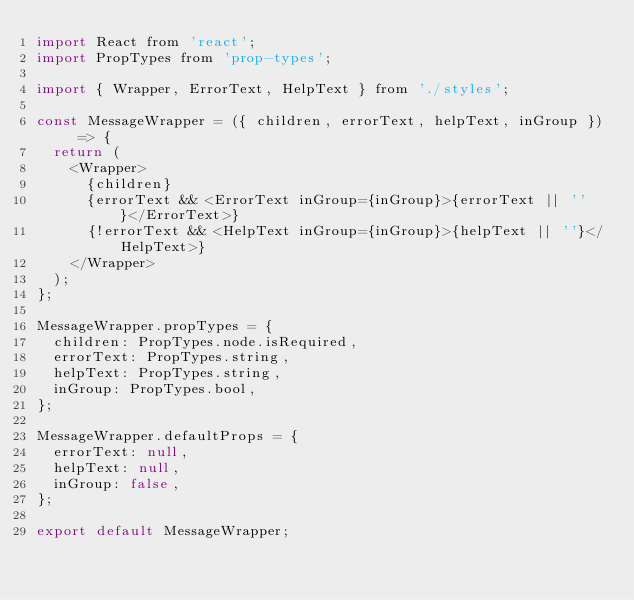Convert code to text. <code><loc_0><loc_0><loc_500><loc_500><_JavaScript_>import React from 'react';
import PropTypes from 'prop-types';

import { Wrapper, ErrorText, HelpText } from './styles';

const MessageWrapper = ({ children, errorText, helpText, inGroup }) => {
  return (
    <Wrapper>
      {children}
      {errorText && <ErrorText inGroup={inGroup}>{errorText || ''}</ErrorText>}
      {!errorText && <HelpText inGroup={inGroup}>{helpText || ''}</HelpText>}
    </Wrapper>
  );
};

MessageWrapper.propTypes = {
  children: PropTypes.node.isRequired,
  errorText: PropTypes.string,
  helpText: PropTypes.string,
  inGroup: PropTypes.bool,
};

MessageWrapper.defaultProps = {
  errorText: null,
  helpText: null,
  inGroup: false,
};

export default MessageWrapper;
</code> 